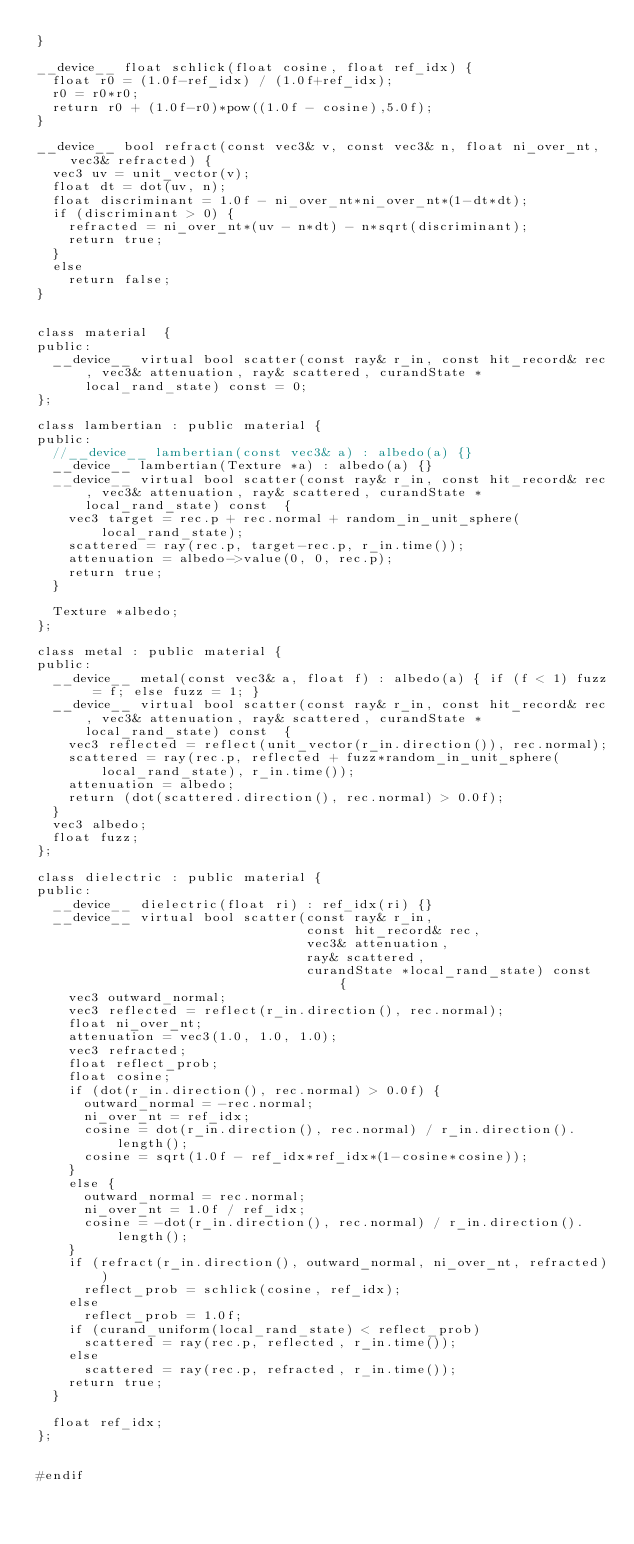<code> <loc_0><loc_0><loc_500><loc_500><_Cuda_>}

__device__ float schlick(float cosine, float ref_idx) {
  float r0 = (1.0f-ref_idx) / (1.0f+ref_idx);
  r0 = r0*r0;
  return r0 + (1.0f-r0)*pow((1.0f - cosine),5.0f);
}

__device__ bool refract(const vec3& v, const vec3& n, float ni_over_nt, vec3& refracted) {
  vec3 uv = unit_vector(v);
  float dt = dot(uv, n);
  float discriminant = 1.0f - ni_over_nt*ni_over_nt*(1-dt*dt);
  if (discriminant > 0) {
    refracted = ni_over_nt*(uv - n*dt) - n*sqrt(discriminant);
    return true;
  }
  else
    return false;
}


class material  {
public:
  __device__ virtual bool scatter(const ray& r_in, const hit_record& rec, vec3& attenuation, ray& scattered, curandState *local_rand_state) const = 0;
};

class lambertian : public material {
public:
  //__device__ lambertian(const vec3& a) : albedo(a) {}
  __device__ lambertian(Texture *a) : albedo(a) {}
  __device__ virtual bool scatter(const ray& r_in, const hit_record& rec, vec3& attenuation, ray& scattered, curandState *local_rand_state) const  {
    vec3 target = rec.p + rec.normal + random_in_unit_sphere(local_rand_state);
    scattered = ray(rec.p, target-rec.p, r_in.time());
    attenuation = albedo->value(0, 0, rec.p);
    return true;
  }

  Texture *albedo;
};

class metal : public material {
public:
  __device__ metal(const vec3& a, float f) : albedo(a) { if (f < 1) fuzz = f; else fuzz = 1; }
  __device__ virtual bool scatter(const ray& r_in, const hit_record& rec, vec3& attenuation, ray& scattered, curandState *local_rand_state) const  {
    vec3 reflected = reflect(unit_vector(r_in.direction()), rec.normal);
    scattered = ray(rec.p, reflected + fuzz*random_in_unit_sphere(local_rand_state), r_in.time());
    attenuation = albedo;
    return (dot(scattered.direction(), rec.normal) > 0.0f);
  }
  vec3 albedo;
  float fuzz;
};

class dielectric : public material {
public:
  __device__ dielectric(float ri) : ref_idx(ri) {}
  __device__ virtual bool scatter(const ray& r_in,
                                  const hit_record& rec,
                                  vec3& attenuation,
                                  ray& scattered,
                                  curandState *local_rand_state) const  {
    vec3 outward_normal;
    vec3 reflected = reflect(r_in.direction(), rec.normal);
    float ni_over_nt;
    attenuation = vec3(1.0, 1.0, 1.0);
    vec3 refracted;
    float reflect_prob;
    float cosine;
    if (dot(r_in.direction(), rec.normal) > 0.0f) {
      outward_normal = -rec.normal;
      ni_over_nt = ref_idx;
      cosine = dot(r_in.direction(), rec.normal) / r_in.direction().length();
      cosine = sqrt(1.0f - ref_idx*ref_idx*(1-cosine*cosine));
    }
    else {
      outward_normal = rec.normal;
      ni_over_nt = 1.0f / ref_idx;
      cosine = -dot(r_in.direction(), rec.normal) / r_in.direction().length();
    }
    if (refract(r_in.direction(), outward_normal, ni_over_nt, refracted))
      reflect_prob = schlick(cosine, ref_idx);
    else
      reflect_prob = 1.0f;
    if (curand_uniform(local_rand_state) < reflect_prob)
      scattered = ray(rec.p, reflected, r_in.time());
    else
      scattered = ray(rec.p, refracted, r_in.time());
    return true;
  }

  float ref_idx;
};


#endif
</code> 